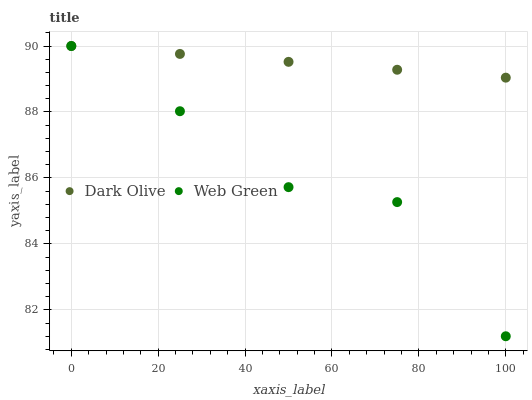Does Web Green have the minimum area under the curve?
Answer yes or no. Yes. Does Dark Olive have the maximum area under the curve?
Answer yes or no. Yes. Does Web Green have the maximum area under the curve?
Answer yes or no. No. Is Dark Olive the smoothest?
Answer yes or no. Yes. Is Web Green the roughest?
Answer yes or no. Yes. Is Web Green the smoothest?
Answer yes or no. No. Does Web Green have the lowest value?
Answer yes or no. Yes. Does Web Green have the highest value?
Answer yes or no. Yes. Does Web Green intersect Dark Olive?
Answer yes or no. Yes. Is Web Green less than Dark Olive?
Answer yes or no. No. Is Web Green greater than Dark Olive?
Answer yes or no. No. 